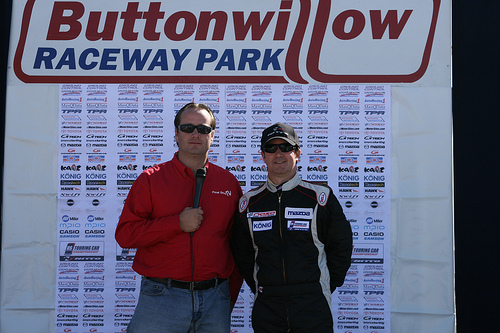<image>
Can you confirm if the man is on the man? No. The man is not positioned on the man. They may be near each other, but the man is not supported by or resting on top of the man. Is there a man to the left of the man? Yes. From this viewpoint, the man is positioned to the left side relative to the man. 